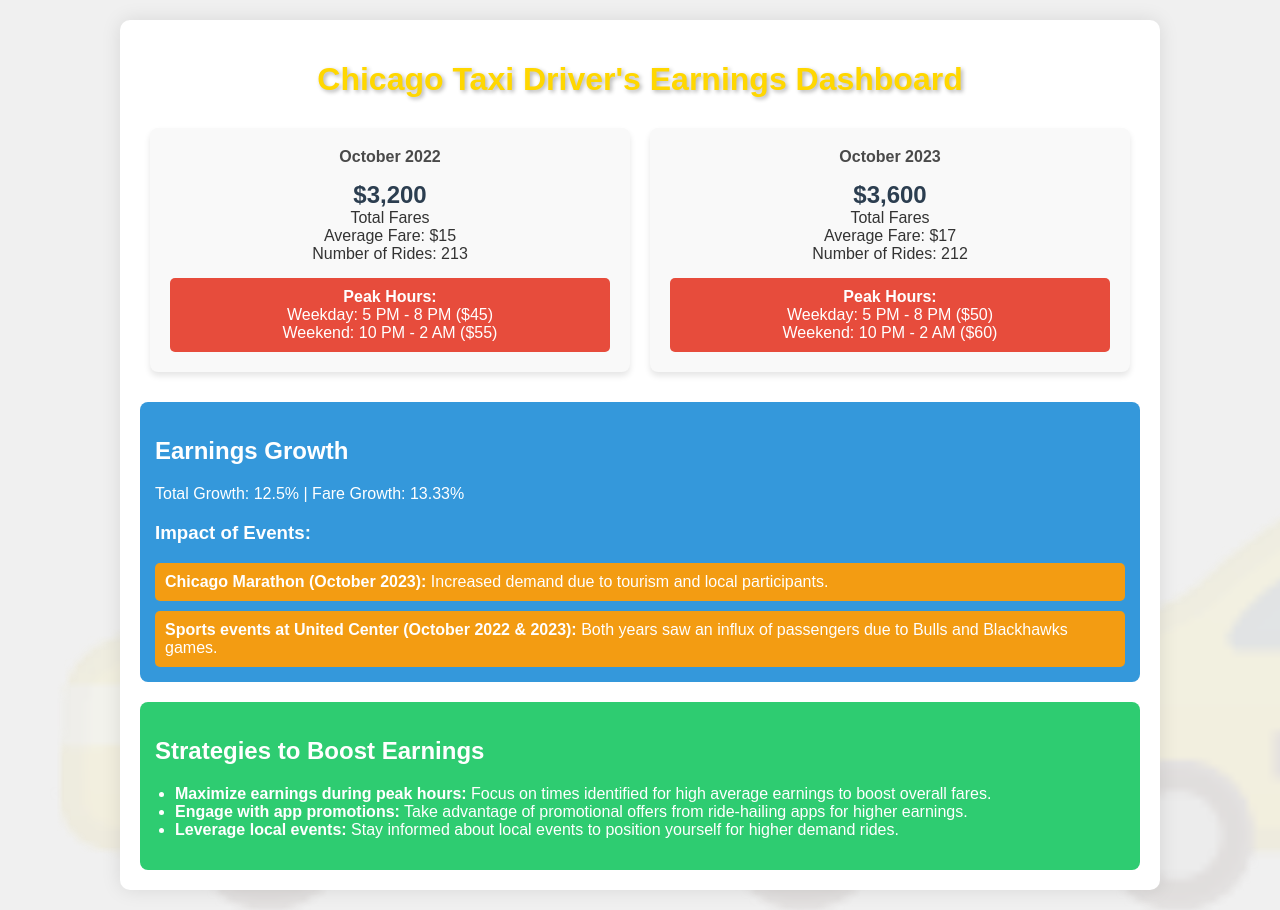What were the total fares for October 2022? The total fares for October 2022 are explicitly mentioned in the document as $3,200.
Answer: $3,200 What was the average fare in October 2023? The average fare for October 2023 is stated in the document as $17.
Answer: $17 What event in October 2023 increased demand? The document mentions the Chicago Marathon as the event that increased demand due to tourism and local participants.
Answer: Chicago Marathon How much was the fare growth from October 2022 to October 2023? The fare growth percentage is calculated in the document as 13.33%.
Answer: 13.33% What were the peak weekend hours for fares in October 2022? The document lists peak weekend hours for October 2022 as 10 PM - 2 AM, while specifying the average fare during these hours as $55.
Answer: 10 PM - 2 AM How many rides were taken in October 2022? The document provides the total number of rides taken in October 2022 as 213.
Answer: 213 What percentage of total growth was recorded from October 2022 to October 2023? The document states that the total growth from October 2022 to October 2023 was 12.5%.
Answer: 12.5% What strategies are recommended to boost earnings? The document lists three strategies in the recommendations section to help boost earnings for taxi drivers.
Answer: Maximize earnings during peak hours, engage with app promotions, leverage local events 